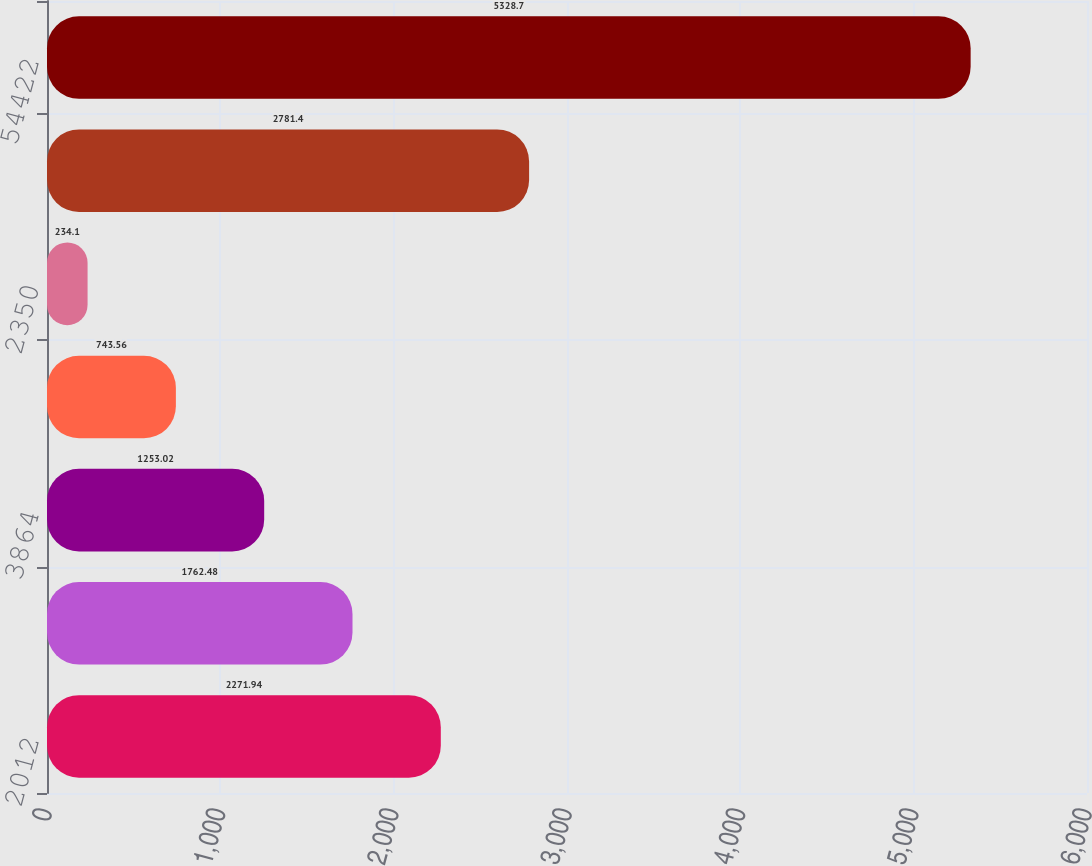Convert chart. <chart><loc_0><loc_0><loc_500><loc_500><bar_chart><fcel>2012<fcel>25687<fcel>3864<fcel>3683<fcel>2350<fcel>18838<fcel>54422<nl><fcel>2271.94<fcel>1762.48<fcel>1253.02<fcel>743.56<fcel>234.1<fcel>2781.4<fcel>5328.7<nl></chart> 